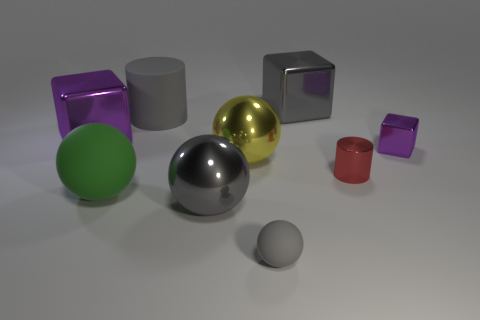Is the yellow ball made of the same material as the large green thing? The yellow ball appears to have a reflective metallic finish, while the large green object has a matte finish, suggesting they are made from different materials. The yellow ball looks similar to materials like polished brass or gold, often used for decorative items, while the large green object resembles a solid color plastic or painted surface commonly used for functional objects. 